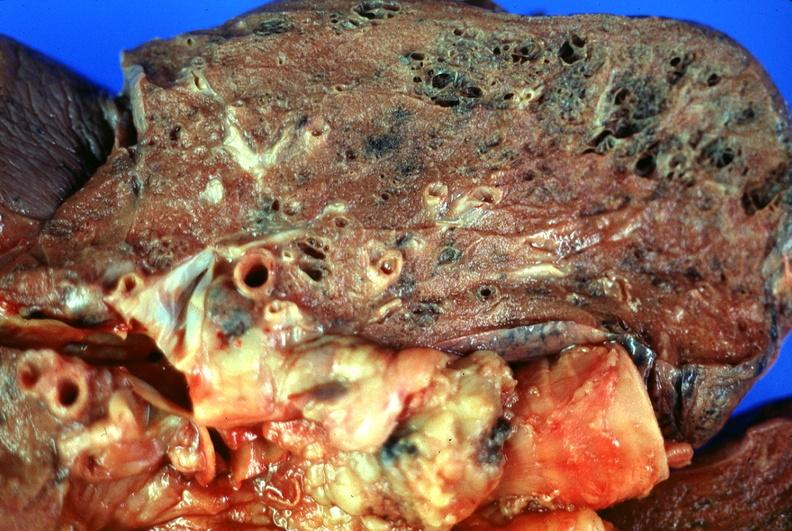s papillary adenoma present?
Answer the question using a single word or phrase. No 